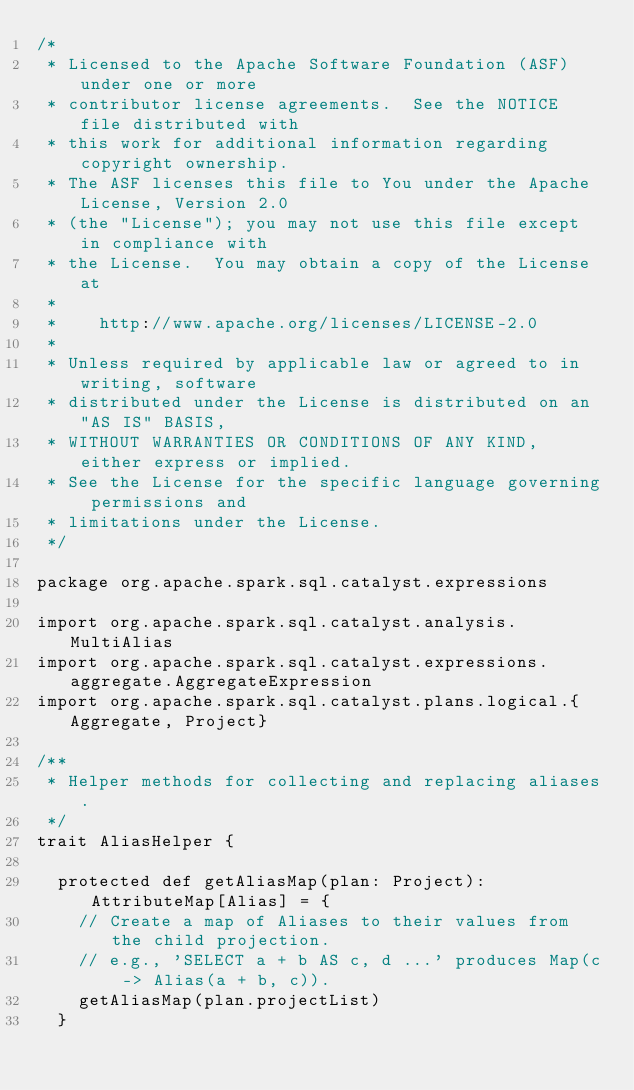<code> <loc_0><loc_0><loc_500><loc_500><_Scala_>/*
 * Licensed to the Apache Software Foundation (ASF) under one or more
 * contributor license agreements.  See the NOTICE file distributed with
 * this work for additional information regarding copyright ownership.
 * The ASF licenses this file to You under the Apache License, Version 2.0
 * (the "License"); you may not use this file except in compliance with
 * the License.  You may obtain a copy of the License at
 *
 *    http://www.apache.org/licenses/LICENSE-2.0
 *
 * Unless required by applicable law or agreed to in writing, software
 * distributed under the License is distributed on an "AS IS" BASIS,
 * WITHOUT WARRANTIES OR CONDITIONS OF ANY KIND, either express or implied.
 * See the License for the specific language governing permissions and
 * limitations under the License.
 */

package org.apache.spark.sql.catalyst.expressions

import org.apache.spark.sql.catalyst.analysis.MultiAlias
import org.apache.spark.sql.catalyst.expressions.aggregate.AggregateExpression
import org.apache.spark.sql.catalyst.plans.logical.{Aggregate, Project}

/**
 * Helper methods for collecting and replacing aliases.
 */
trait AliasHelper {

  protected def getAliasMap(plan: Project): AttributeMap[Alias] = {
    // Create a map of Aliases to their values from the child projection.
    // e.g., 'SELECT a + b AS c, d ...' produces Map(c -> Alias(a + b, c)).
    getAliasMap(plan.projectList)
  }
</code> 